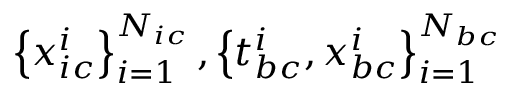Convert formula to latex. <formula><loc_0><loc_0><loc_500><loc_500>\left \{ x _ { i c } ^ { i } \right \} _ { i = 1 } ^ { N _ { i c } } , \left \{ t _ { b c } ^ { i } , x _ { b c } ^ { i } \right \} _ { i = 1 } ^ { N _ { b c } }</formula> 